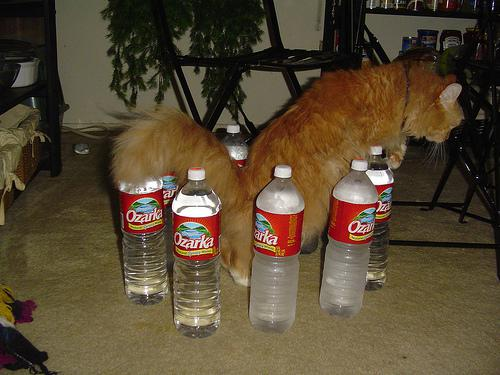Question: what is the focus?
Choices:
A. Cat sleeping.
B. Cat eating.
C. Cat playing with ball.
D. Cat rubbing on water bottles.
Answer with the letter. Answer: D Question: why are two of the bottles dripping?
Choices:
A. Overflow.
B. Leaks.
C. Condensation.
D. Tipped on side.
Answer with the letter. Answer: C Question: what color is the cat?
Choices:
A. Orange.
B. Red.
C. Yellow.
D. Blue.
Answer with the letter. Answer: A Question: how many cats are shown?
Choices:
A. 2.
B. 3.
C. 1.
D. 5.
Answer with the letter. Answer: C Question: how many people are in the photo?
Choices:
A. 0.
B. 1.
C. 3.
D. 4.
Answer with the letter. Answer: A Question: what brand water bottles are they?
Choices:
A. Calistoga.
B. Perrier.
C. Ozarka.
D. Alhambra.
Answer with the letter. Answer: C Question: where is this shot?
Choices:
A. Bedroom.
B. Living room.
C. Kitchen.
D. Bathroom.
Answer with the letter. Answer: B 